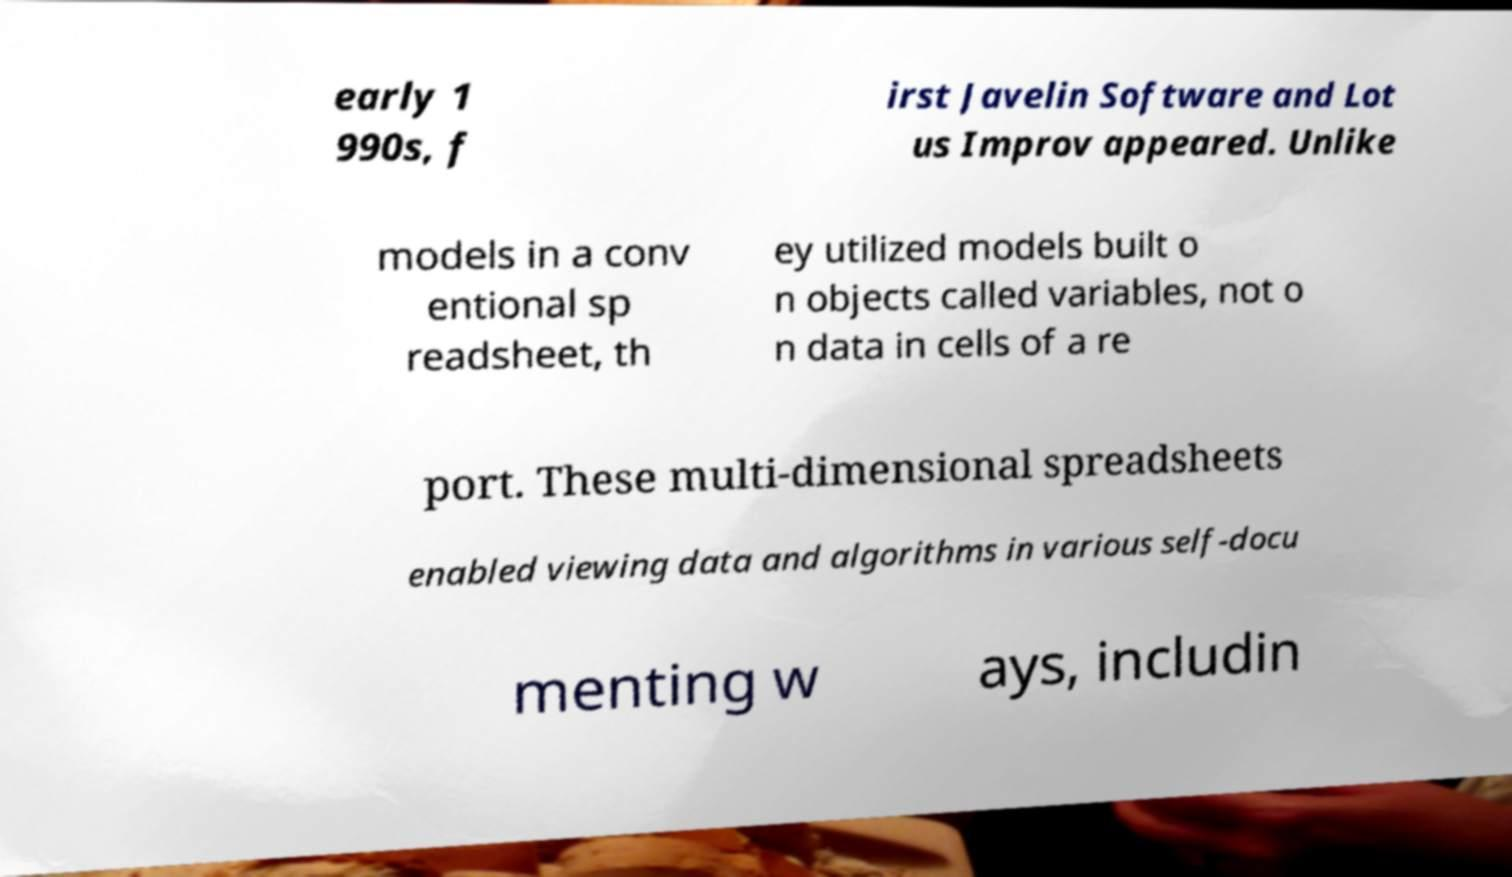What messages or text are displayed in this image? I need them in a readable, typed format. early 1 990s, f irst Javelin Software and Lot us Improv appeared. Unlike models in a conv entional sp readsheet, th ey utilized models built o n objects called variables, not o n data in cells of a re port. These multi-dimensional spreadsheets enabled viewing data and algorithms in various self-docu menting w ays, includin 